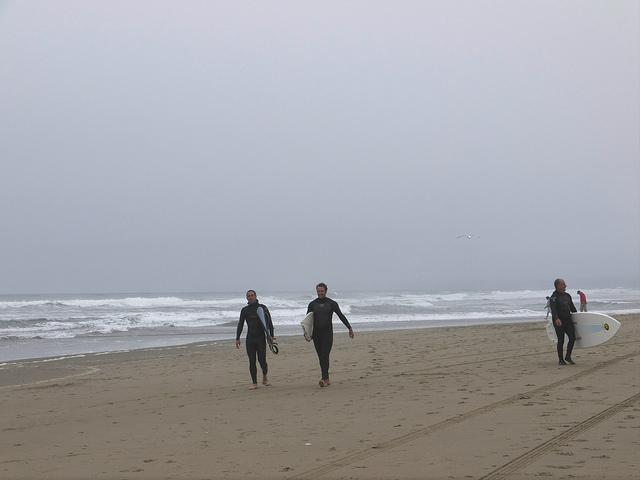The lines on the sand were made by what part of a vehicle?

Choices:
A) trunk
B) tires
C) motor
D) bumper tires 